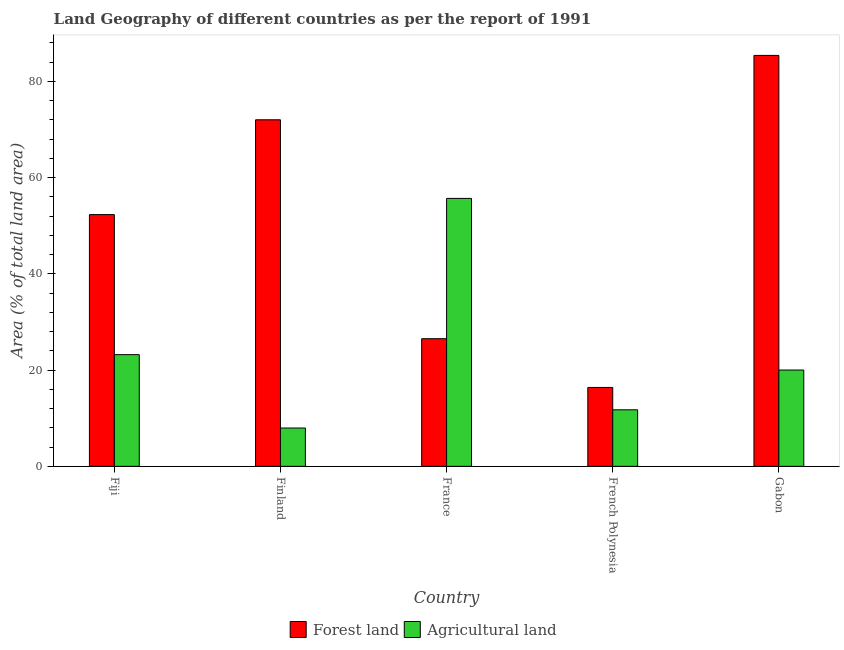How many different coloured bars are there?
Provide a short and direct response. 2. Are the number of bars on each tick of the X-axis equal?
Offer a terse response. Yes. How many bars are there on the 1st tick from the left?
Your answer should be very brief. 2. What is the label of the 1st group of bars from the left?
Give a very brief answer. Fiji. What is the percentage of land area under forests in Finland?
Provide a short and direct response. 72. Across all countries, what is the maximum percentage of land area under forests?
Your answer should be very brief. 85.38. Across all countries, what is the minimum percentage of land area under agriculture?
Offer a terse response. 7.96. In which country was the percentage of land area under forests minimum?
Offer a very short reply. French Polynesia. What is the total percentage of land area under agriculture in the graph?
Give a very brief answer. 118.6. What is the difference between the percentage of land area under forests in France and that in French Polynesia?
Ensure brevity in your answer.  10.13. What is the difference between the percentage of land area under agriculture in Fiji and the percentage of land area under forests in France?
Keep it short and to the point. -3.31. What is the average percentage of land area under agriculture per country?
Make the answer very short. 23.72. What is the difference between the percentage of land area under agriculture and percentage of land area under forests in French Polynesia?
Your answer should be compact. -4.64. In how many countries, is the percentage of land area under forests greater than 56 %?
Provide a short and direct response. 2. What is the ratio of the percentage of land area under forests in France to that in French Polynesia?
Provide a short and direct response. 1.62. What is the difference between the highest and the second highest percentage of land area under forests?
Keep it short and to the point. 13.38. What is the difference between the highest and the lowest percentage of land area under agriculture?
Provide a succinct answer. 47.71. Is the sum of the percentage of land area under forests in Fiji and French Polynesia greater than the maximum percentage of land area under agriculture across all countries?
Your answer should be compact. Yes. What does the 2nd bar from the left in Fiji represents?
Ensure brevity in your answer.  Agricultural land. What does the 1st bar from the right in Fiji represents?
Offer a terse response. Agricultural land. Are all the bars in the graph horizontal?
Keep it short and to the point. No. What is the difference between two consecutive major ticks on the Y-axis?
Provide a short and direct response. 20. Does the graph contain grids?
Your answer should be very brief. No. How are the legend labels stacked?
Provide a short and direct response. Horizontal. What is the title of the graph?
Keep it short and to the point. Land Geography of different countries as per the report of 1991. What is the label or title of the Y-axis?
Keep it short and to the point. Area (% of total land area). What is the Area (% of total land area) in Forest land in Fiji?
Provide a short and direct response. 52.31. What is the Area (% of total land area) of Agricultural land in Fiji?
Provide a succinct answer. 23.21. What is the Area (% of total land area) of Forest land in Finland?
Make the answer very short. 72. What is the Area (% of total land area) of Agricultural land in Finland?
Make the answer very short. 7.96. What is the Area (% of total land area) in Forest land in France?
Your answer should be very brief. 26.52. What is the Area (% of total land area) in Agricultural land in France?
Offer a very short reply. 55.67. What is the Area (% of total land area) of Forest land in French Polynesia?
Make the answer very short. 16.39. What is the Area (% of total land area) in Agricultural land in French Polynesia?
Keep it short and to the point. 11.75. What is the Area (% of total land area) of Forest land in Gabon?
Provide a short and direct response. 85.38. What is the Area (% of total land area) of Agricultural land in Gabon?
Offer a terse response. 20.01. Across all countries, what is the maximum Area (% of total land area) of Forest land?
Offer a very short reply. 85.38. Across all countries, what is the maximum Area (% of total land area) of Agricultural land?
Keep it short and to the point. 55.67. Across all countries, what is the minimum Area (% of total land area) of Forest land?
Make the answer very short. 16.39. Across all countries, what is the minimum Area (% of total land area) of Agricultural land?
Your answer should be very brief. 7.96. What is the total Area (% of total land area) in Forest land in the graph?
Your answer should be very brief. 252.61. What is the total Area (% of total land area) in Agricultural land in the graph?
Ensure brevity in your answer.  118.6. What is the difference between the Area (% of total land area) of Forest land in Fiji and that in Finland?
Offer a very short reply. -19.7. What is the difference between the Area (% of total land area) in Agricultural land in Fiji and that in Finland?
Provide a succinct answer. 15.25. What is the difference between the Area (% of total land area) in Forest land in Fiji and that in France?
Make the answer very short. 25.79. What is the difference between the Area (% of total land area) of Agricultural land in Fiji and that in France?
Ensure brevity in your answer.  -32.47. What is the difference between the Area (% of total land area) in Forest land in Fiji and that in French Polynesia?
Ensure brevity in your answer.  35.91. What is the difference between the Area (% of total land area) in Agricultural land in Fiji and that in French Polynesia?
Offer a terse response. 11.46. What is the difference between the Area (% of total land area) in Forest land in Fiji and that in Gabon?
Your answer should be very brief. -33.07. What is the difference between the Area (% of total land area) in Agricultural land in Fiji and that in Gabon?
Your answer should be very brief. 3.19. What is the difference between the Area (% of total land area) in Forest land in Finland and that in France?
Provide a short and direct response. 45.49. What is the difference between the Area (% of total land area) of Agricultural land in Finland and that in France?
Provide a succinct answer. -47.71. What is the difference between the Area (% of total land area) of Forest land in Finland and that in French Polynesia?
Provide a succinct answer. 55.61. What is the difference between the Area (% of total land area) in Agricultural land in Finland and that in French Polynesia?
Provide a succinct answer. -3.79. What is the difference between the Area (% of total land area) of Forest land in Finland and that in Gabon?
Provide a succinct answer. -13.38. What is the difference between the Area (% of total land area) in Agricultural land in Finland and that in Gabon?
Offer a terse response. -12.05. What is the difference between the Area (% of total land area) in Forest land in France and that in French Polynesia?
Provide a short and direct response. 10.13. What is the difference between the Area (% of total land area) of Agricultural land in France and that in French Polynesia?
Provide a short and direct response. 43.92. What is the difference between the Area (% of total land area) of Forest land in France and that in Gabon?
Your answer should be compact. -58.86. What is the difference between the Area (% of total land area) of Agricultural land in France and that in Gabon?
Provide a short and direct response. 35.66. What is the difference between the Area (% of total land area) in Forest land in French Polynesia and that in Gabon?
Give a very brief answer. -68.99. What is the difference between the Area (% of total land area) of Agricultural land in French Polynesia and that in Gabon?
Your response must be concise. -8.27. What is the difference between the Area (% of total land area) of Forest land in Fiji and the Area (% of total land area) of Agricultural land in Finland?
Make the answer very short. 44.35. What is the difference between the Area (% of total land area) of Forest land in Fiji and the Area (% of total land area) of Agricultural land in France?
Provide a succinct answer. -3.37. What is the difference between the Area (% of total land area) in Forest land in Fiji and the Area (% of total land area) in Agricultural land in French Polynesia?
Ensure brevity in your answer.  40.56. What is the difference between the Area (% of total land area) of Forest land in Fiji and the Area (% of total land area) of Agricultural land in Gabon?
Keep it short and to the point. 32.29. What is the difference between the Area (% of total land area) of Forest land in Finland and the Area (% of total land area) of Agricultural land in France?
Your response must be concise. 16.33. What is the difference between the Area (% of total land area) in Forest land in Finland and the Area (% of total land area) in Agricultural land in French Polynesia?
Provide a succinct answer. 60.26. What is the difference between the Area (% of total land area) of Forest land in Finland and the Area (% of total land area) of Agricultural land in Gabon?
Offer a very short reply. 51.99. What is the difference between the Area (% of total land area) of Forest land in France and the Area (% of total land area) of Agricultural land in French Polynesia?
Provide a succinct answer. 14.77. What is the difference between the Area (% of total land area) of Forest land in France and the Area (% of total land area) of Agricultural land in Gabon?
Your response must be concise. 6.51. What is the difference between the Area (% of total land area) of Forest land in French Polynesia and the Area (% of total land area) of Agricultural land in Gabon?
Provide a succinct answer. -3.62. What is the average Area (% of total land area) in Forest land per country?
Make the answer very short. 50.52. What is the average Area (% of total land area) of Agricultural land per country?
Give a very brief answer. 23.72. What is the difference between the Area (% of total land area) of Forest land and Area (% of total land area) of Agricultural land in Fiji?
Your answer should be very brief. 29.1. What is the difference between the Area (% of total land area) of Forest land and Area (% of total land area) of Agricultural land in Finland?
Your answer should be very brief. 64.04. What is the difference between the Area (% of total land area) of Forest land and Area (% of total land area) of Agricultural land in France?
Make the answer very short. -29.15. What is the difference between the Area (% of total land area) in Forest land and Area (% of total land area) in Agricultural land in French Polynesia?
Keep it short and to the point. 4.64. What is the difference between the Area (% of total land area) in Forest land and Area (% of total land area) in Agricultural land in Gabon?
Offer a terse response. 65.37. What is the ratio of the Area (% of total land area) of Forest land in Fiji to that in Finland?
Your answer should be compact. 0.73. What is the ratio of the Area (% of total land area) in Agricultural land in Fiji to that in Finland?
Keep it short and to the point. 2.92. What is the ratio of the Area (% of total land area) of Forest land in Fiji to that in France?
Keep it short and to the point. 1.97. What is the ratio of the Area (% of total land area) in Agricultural land in Fiji to that in France?
Keep it short and to the point. 0.42. What is the ratio of the Area (% of total land area) of Forest land in Fiji to that in French Polynesia?
Keep it short and to the point. 3.19. What is the ratio of the Area (% of total land area) in Agricultural land in Fiji to that in French Polynesia?
Your answer should be compact. 1.98. What is the ratio of the Area (% of total land area) of Forest land in Fiji to that in Gabon?
Keep it short and to the point. 0.61. What is the ratio of the Area (% of total land area) in Agricultural land in Fiji to that in Gabon?
Make the answer very short. 1.16. What is the ratio of the Area (% of total land area) of Forest land in Finland to that in France?
Your answer should be very brief. 2.72. What is the ratio of the Area (% of total land area) in Agricultural land in Finland to that in France?
Ensure brevity in your answer.  0.14. What is the ratio of the Area (% of total land area) of Forest land in Finland to that in French Polynesia?
Your answer should be very brief. 4.39. What is the ratio of the Area (% of total land area) of Agricultural land in Finland to that in French Polynesia?
Ensure brevity in your answer.  0.68. What is the ratio of the Area (% of total land area) of Forest land in Finland to that in Gabon?
Offer a very short reply. 0.84. What is the ratio of the Area (% of total land area) of Agricultural land in Finland to that in Gabon?
Provide a short and direct response. 0.4. What is the ratio of the Area (% of total land area) of Forest land in France to that in French Polynesia?
Keep it short and to the point. 1.62. What is the ratio of the Area (% of total land area) of Agricultural land in France to that in French Polynesia?
Make the answer very short. 4.74. What is the ratio of the Area (% of total land area) of Forest land in France to that in Gabon?
Offer a very short reply. 0.31. What is the ratio of the Area (% of total land area) in Agricultural land in France to that in Gabon?
Ensure brevity in your answer.  2.78. What is the ratio of the Area (% of total land area) of Forest land in French Polynesia to that in Gabon?
Your answer should be compact. 0.19. What is the ratio of the Area (% of total land area) of Agricultural land in French Polynesia to that in Gabon?
Provide a succinct answer. 0.59. What is the difference between the highest and the second highest Area (% of total land area) in Forest land?
Offer a very short reply. 13.38. What is the difference between the highest and the second highest Area (% of total land area) in Agricultural land?
Provide a short and direct response. 32.47. What is the difference between the highest and the lowest Area (% of total land area) in Forest land?
Give a very brief answer. 68.99. What is the difference between the highest and the lowest Area (% of total land area) in Agricultural land?
Offer a terse response. 47.71. 